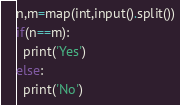Convert code to text. <code><loc_0><loc_0><loc_500><loc_500><_Python_>n,m=map(int,input().split())
if(n==m):
  print('Yes')
else:
  print('No')
</code> 